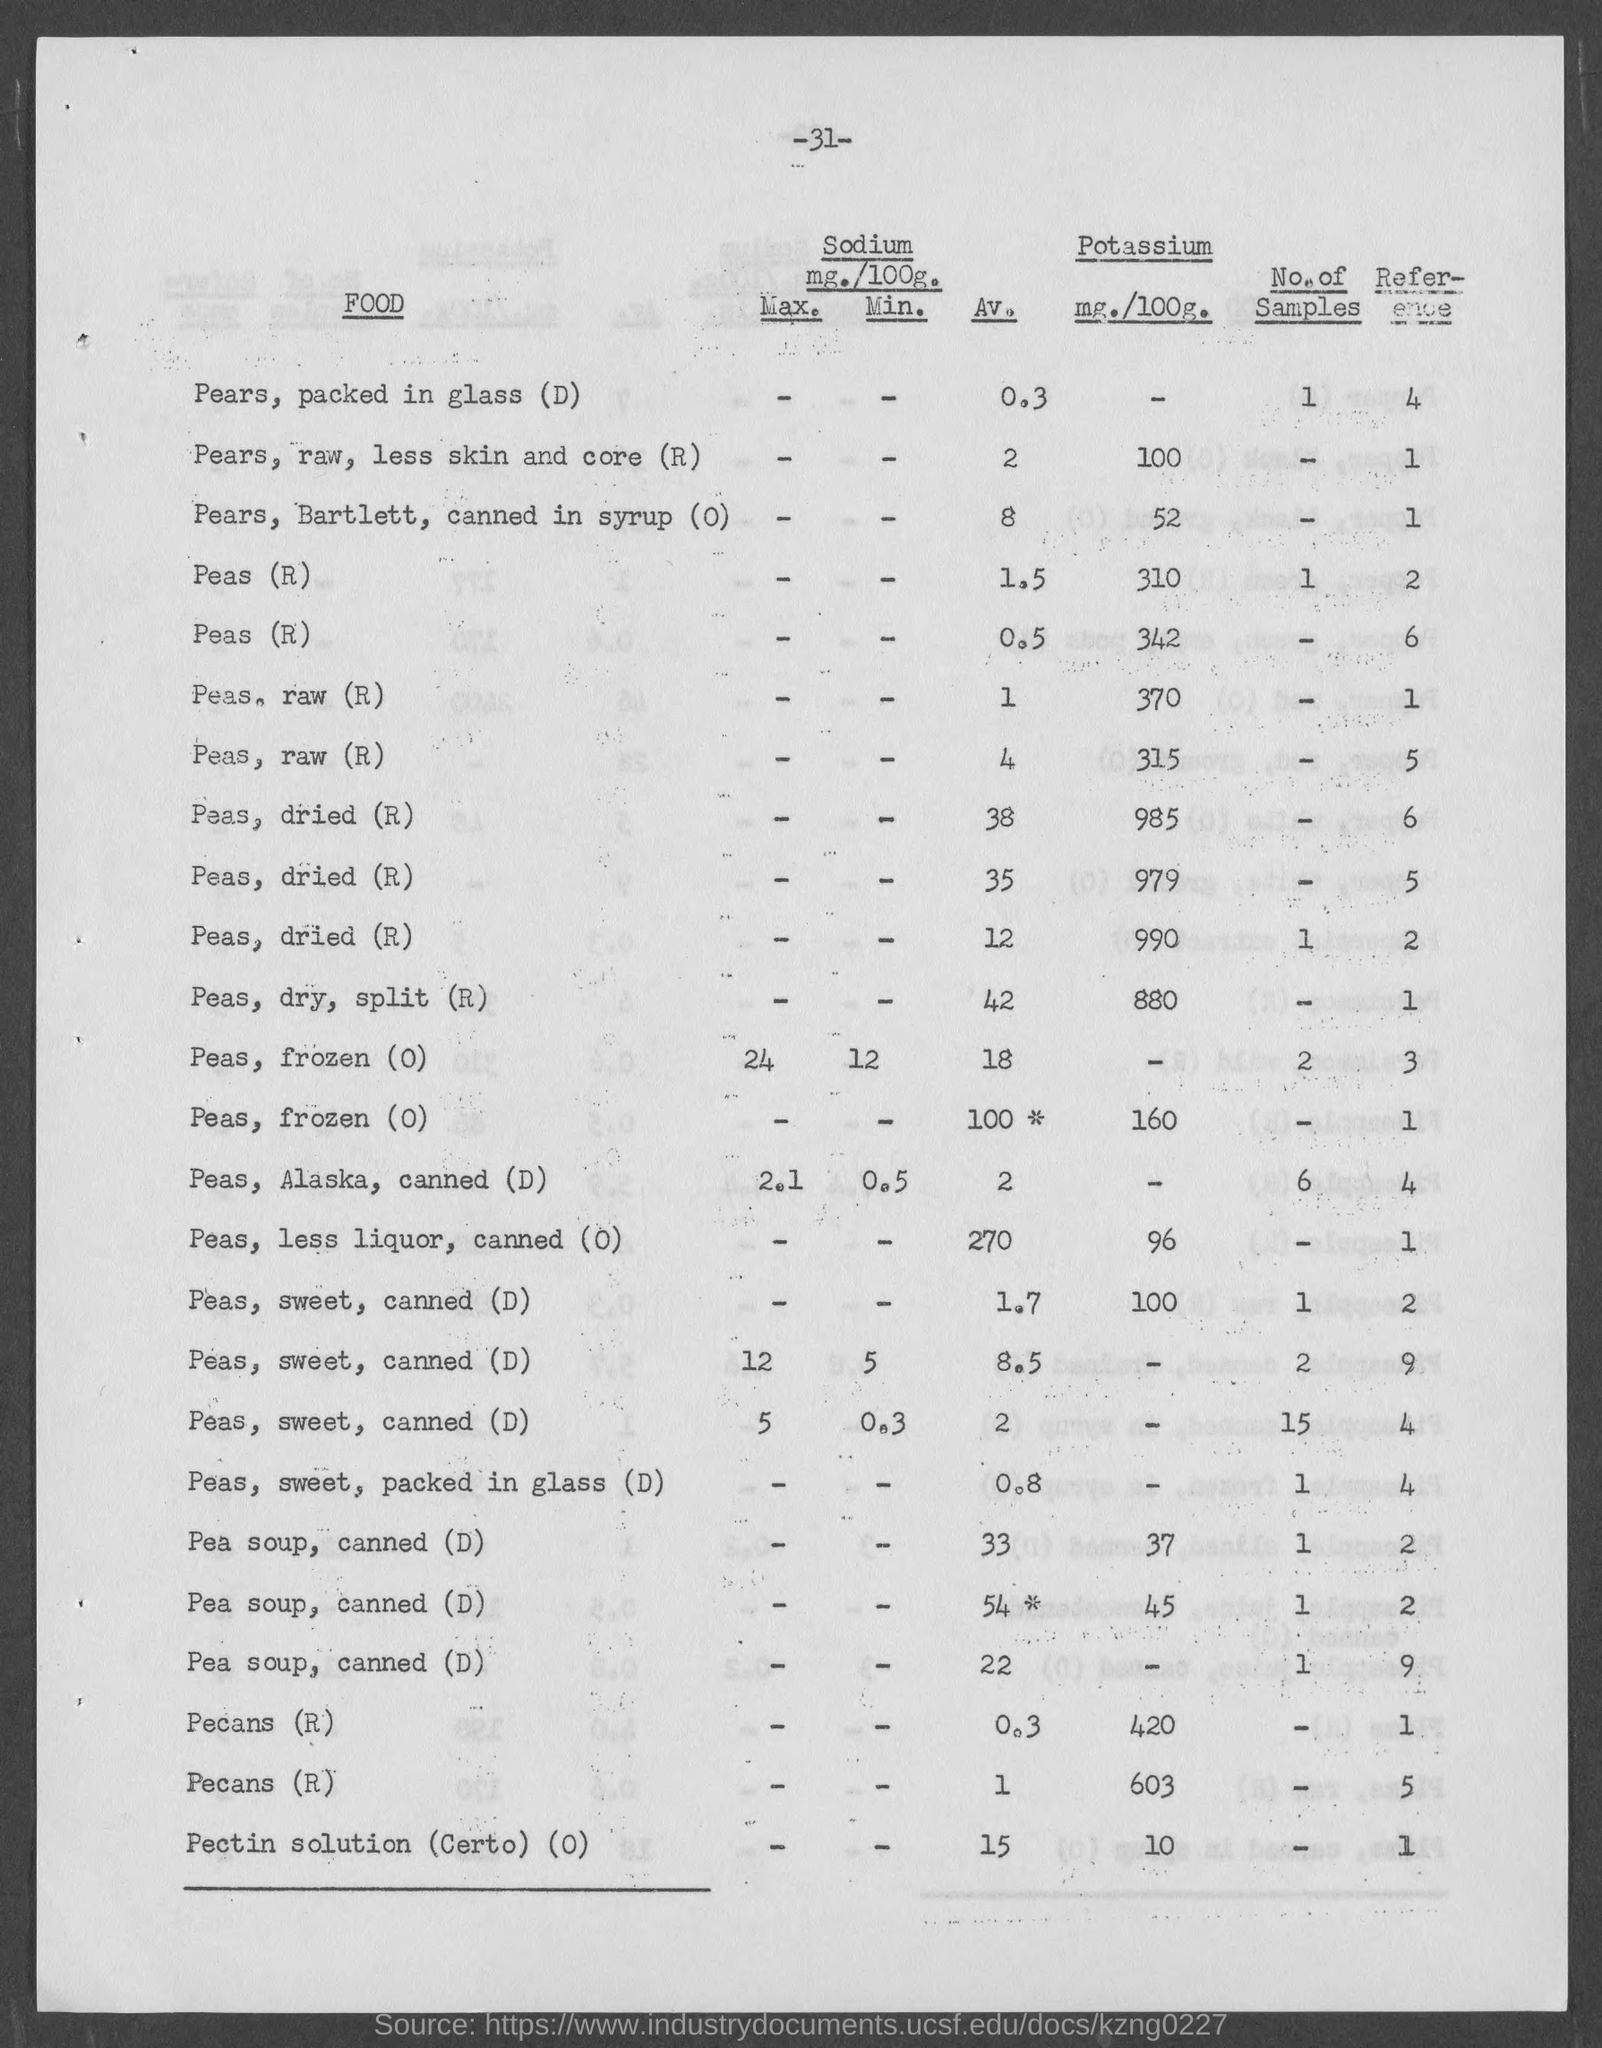Mention a couple of crucial points in this snapshot. The amount of Potassium in 100 grams of Pears,raw, without the skin and core is 100 milligrams. The amount of Potassium in 100 grams of Barlett pears, canned in syrup (O) is 52 milligrams. The amount of Potassium in 100 grams of Pectin solution (Certo) is 10 milligrams. The number at the top of the page is -31-, and it is followed by a period. The amount of Potassium in 100 grams of canned, low-sodium peas (O) is 96 milligrams. 